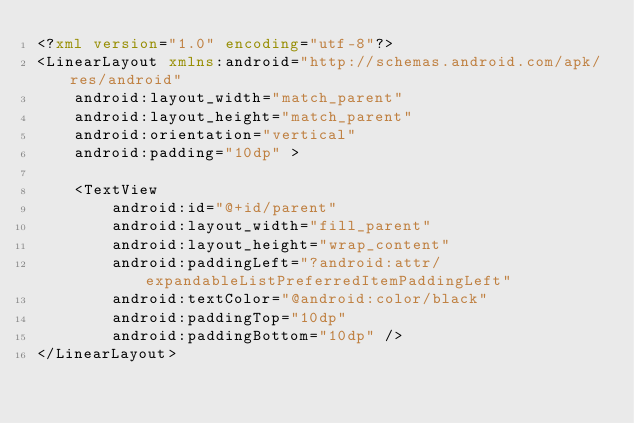Convert code to text. <code><loc_0><loc_0><loc_500><loc_500><_XML_><?xml version="1.0" encoding="utf-8"?>
<LinearLayout xmlns:android="http://schemas.android.com/apk/res/android"
    android:layout_width="match_parent"
    android:layout_height="match_parent"
    android:orientation="vertical"
    android:padding="10dp" >

    <TextView
        android:id="@+id/parent"
        android:layout_width="fill_parent"
        android:layout_height="wrap_content"
        android:paddingLeft="?android:attr/expandableListPreferredItemPaddingLeft"
        android:textColor="@android:color/black"
        android:paddingTop="10dp"
        android:paddingBottom="10dp" />
</LinearLayout></code> 